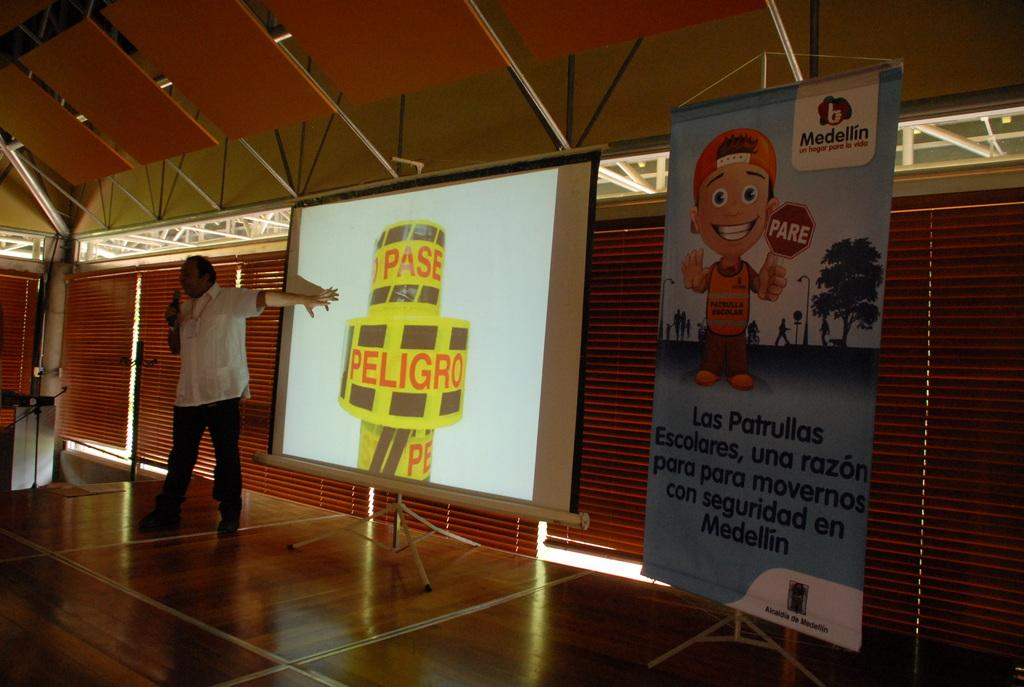Who is present in the image? There is a man in the image. What is the man holding in the image? The man is holding a microphone. What can be seen on the wall in the image? There is a projector screen and a hoarding in the image. What materials are visible in the background of the image? Metal rods and window blinds are visible in the background of the image. What type of gold jewelry is the man wearing in the image? There is no gold jewelry visible on the man in the image. Are there any bears present in the image? No, there are no bears present in the image. 